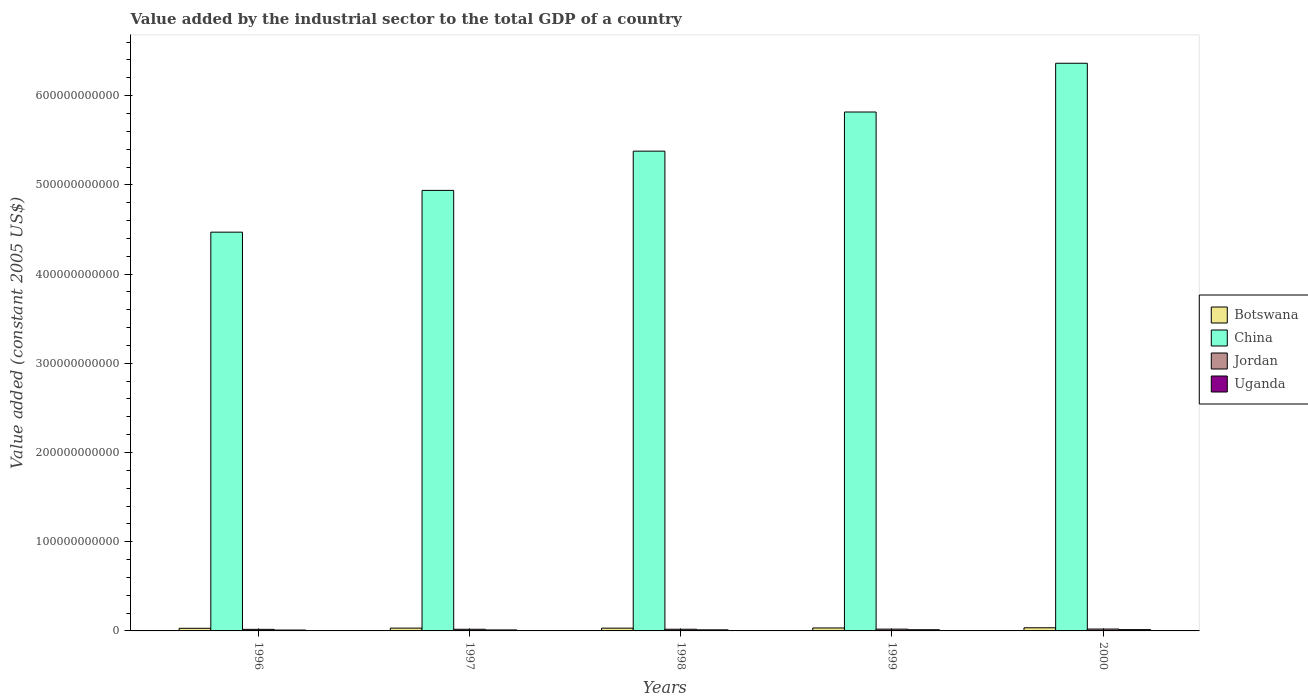Are the number of bars per tick equal to the number of legend labels?
Give a very brief answer. Yes. Are the number of bars on each tick of the X-axis equal?
Keep it short and to the point. Yes. How many bars are there on the 2nd tick from the left?
Make the answer very short. 4. What is the value added by the industrial sector in Uganda in 1997?
Offer a terse response. 1.10e+09. Across all years, what is the maximum value added by the industrial sector in Uganda?
Provide a succinct answer. 1.45e+09. Across all years, what is the minimum value added by the industrial sector in Uganda?
Give a very brief answer. 9.84e+08. In which year was the value added by the industrial sector in China maximum?
Your answer should be compact. 2000. In which year was the value added by the industrial sector in Jordan minimum?
Your answer should be compact. 1996. What is the total value added by the industrial sector in Jordan in the graph?
Keep it short and to the point. 9.58e+09. What is the difference between the value added by the industrial sector in Botswana in 1998 and that in 1999?
Provide a succinct answer. -2.07e+08. What is the difference between the value added by the industrial sector in Botswana in 1998 and the value added by the industrial sector in China in 1999?
Offer a very short reply. -5.79e+11. What is the average value added by the industrial sector in Uganda per year?
Offer a terse response. 1.21e+09. In the year 1999, what is the difference between the value added by the industrial sector in Botswana and value added by the industrial sector in Jordan?
Provide a succinct answer. 1.30e+09. What is the ratio of the value added by the industrial sector in China in 1997 to that in 1999?
Give a very brief answer. 0.85. Is the difference between the value added by the industrial sector in Botswana in 1998 and 2000 greater than the difference between the value added by the industrial sector in Jordan in 1998 and 2000?
Keep it short and to the point. No. What is the difference between the highest and the second highest value added by the industrial sector in Botswana?
Keep it short and to the point. 2.25e+08. What is the difference between the highest and the lowest value added by the industrial sector in Botswana?
Provide a succinct answer. 5.79e+08. Is it the case that in every year, the sum of the value added by the industrial sector in China and value added by the industrial sector in Botswana is greater than the sum of value added by the industrial sector in Jordan and value added by the industrial sector in Uganda?
Make the answer very short. Yes. What does the 1st bar from the left in 1996 represents?
Keep it short and to the point. Botswana. What does the 2nd bar from the right in 1996 represents?
Your response must be concise. Jordan. Is it the case that in every year, the sum of the value added by the industrial sector in Botswana and value added by the industrial sector in Jordan is greater than the value added by the industrial sector in China?
Provide a succinct answer. No. Are all the bars in the graph horizontal?
Ensure brevity in your answer.  No. What is the difference between two consecutive major ticks on the Y-axis?
Provide a short and direct response. 1.00e+11. Are the values on the major ticks of Y-axis written in scientific E-notation?
Provide a succinct answer. No. Does the graph contain any zero values?
Keep it short and to the point. No. Where does the legend appear in the graph?
Provide a succinct answer. Center right. How many legend labels are there?
Provide a succinct answer. 4. How are the legend labels stacked?
Provide a succinct answer. Vertical. What is the title of the graph?
Offer a very short reply. Value added by the industrial sector to the total GDP of a country. Does "Macedonia" appear as one of the legend labels in the graph?
Offer a terse response. No. What is the label or title of the Y-axis?
Give a very brief answer. Value added (constant 2005 US$). What is the Value added (constant 2005 US$) in Botswana in 1996?
Make the answer very short. 2.96e+09. What is the Value added (constant 2005 US$) of China in 1996?
Your answer should be compact. 4.47e+11. What is the Value added (constant 2005 US$) of Jordan in 1996?
Provide a short and direct response. 1.76e+09. What is the Value added (constant 2005 US$) in Uganda in 1996?
Provide a short and direct response. 9.84e+08. What is the Value added (constant 2005 US$) of Botswana in 1997?
Make the answer very short. 3.15e+09. What is the Value added (constant 2005 US$) in China in 1997?
Provide a succinct answer. 4.94e+11. What is the Value added (constant 2005 US$) in Jordan in 1997?
Give a very brief answer. 1.85e+09. What is the Value added (constant 2005 US$) of Uganda in 1997?
Keep it short and to the point. 1.10e+09. What is the Value added (constant 2005 US$) in Botswana in 1998?
Keep it short and to the point. 3.10e+09. What is the Value added (constant 2005 US$) in China in 1998?
Your response must be concise. 5.38e+11. What is the Value added (constant 2005 US$) in Jordan in 1998?
Your answer should be compact. 1.88e+09. What is the Value added (constant 2005 US$) in Uganda in 1998?
Keep it short and to the point. 1.19e+09. What is the Value added (constant 2005 US$) in Botswana in 1999?
Offer a very short reply. 3.31e+09. What is the Value added (constant 2005 US$) in China in 1999?
Your answer should be very brief. 5.82e+11. What is the Value added (constant 2005 US$) of Jordan in 1999?
Make the answer very short. 2.01e+09. What is the Value added (constant 2005 US$) in Uganda in 1999?
Give a very brief answer. 1.31e+09. What is the Value added (constant 2005 US$) in Botswana in 2000?
Provide a succinct answer. 3.54e+09. What is the Value added (constant 2005 US$) of China in 2000?
Your answer should be compact. 6.36e+11. What is the Value added (constant 2005 US$) in Jordan in 2000?
Provide a succinct answer. 2.09e+09. What is the Value added (constant 2005 US$) in Uganda in 2000?
Give a very brief answer. 1.45e+09. Across all years, what is the maximum Value added (constant 2005 US$) of Botswana?
Keep it short and to the point. 3.54e+09. Across all years, what is the maximum Value added (constant 2005 US$) of China?
Ensure brevity in your answer.  6.36e+11. Across all years, what is the maximum Value added (constant 2005 US$) of Jordan?
Your answer should be compact. 2.09e+09. Across all years, what is the maximum Value added (constant 2005 US$) of Uganda?
Offer a very short reply. 1.45e+09. Across all years, what is the minimum Value added (constant 2005 US$) of Botswana?
Your response must be concise. 2.96e+09. Across all years, what is the minimum Value added (constant 2005 US$) in China?
Your answer should be very brief. 4.47e+11. Across all years, what is the minimum Value added (constant 2005 US$) in Jordan?
Keep it short and to the point. 1.76e+09. Across all years, what is the minimum Value added (constant 2005 US$) in Uganda?
Give a very brief answer. 9.84e+08. What is the total Value added (constant 2005 US$) of Botswana in the graph?
Your answer should be compact. 1.61e+1. What is the total Value added (constant 2005 US$) in China in the graph?
Your answer should be very brief. 2.70e+12. What is the total Value added (constant 2005 US$) in Jordan in the graph?
Provide a short and direct response. 9.58e+09. What is the total Value added (constant 2005 US$) in Uganda in the graph?
Your answer should be very brief. 6.03e+09. What is the difference between the Value added (constant 2005 US$) of Botswana in 1996 and that in 1997?
Provide a short and direct response. -1.94e+08. What is the difference between the Value added (constant 2005 US$) in China in 1996 and that in 1997?
Your answer should be compact. -4.68e+1. What is the difference between the Value added (constant 2005 US$) in Jordan in 1996 and that in 1997?
Offer a very short reply. -9.61e+07. What is the difference between the Value added (constant 2005 US$) in Uganda in 1996 and that in 1997?
Offer a terse response. -1.12e+08. What is the difference between the Value added (constant 2005 US$) of Botswana in 1996 and that in 1998?
Make the answer very short. -1.46e+08. What is the difference between the Value added (constant 2005 US$) in China in 1996 and that in 1998?
Your answer should be very brief. -9.08e+1. What is the difference between the Value added (constant 2005 US$) in Jordan in 1996 and that in 1998?
Keep it short and to the point. -1.24e+08. What is the difference between the Value added (constant 2005 US$) of Uganda in 1996 and that in 1998?
Provide a short and direct response. -2.07e+08. What is the difference between the Value added (constant 2005 US$) of Botswana in 1996 and that in 1999?
Your answer should be compact. -3.53e+08. What is the difference between the Value added (constant 2005 US$) of China in 1996 and that in 1999?
Provide a succinct answer. -1.35e+11. What is the difference between the Value added (constant 2005 US$) in Jordan in 1996 and that in 1999?
Offer a terse response. -2.50e+08. What is the difference between the Value added (constant 2005 US$) of Uganda in 1996 and that in 1999?
Keep it short and to the point. -3.31e+08. What is the difference between the Value added (constant 2005 US$) in Botswana in 1996 and that in 2000?
Offer a terse response. -5.79e+08. What is the difference between the Value added (constant 2005 US$) in China in 1996 and that in 2000?
Provide a short and direct response. -1.89e+11. What is the difference between the Value added (constant 2005 US$) in Jordan in 1996 and that in 2000?
Make the answer very short. -3.32e+08. What is the difference between the Value added (constant 2005 US$) of Uganda in 1996 and that in 2000?
Your answer should be very brief. -4.65e+08. What is the difference between the Value added (constant 2005 US$) of Botswana in 1997 and that in 1998?
Your answer should be very brief. 4.81e+07. What is the difference between the Value added (constant 2005 US$) of China in 1997 and that in 1998?
Ensure brevity in your answer.  -4.40e+1. What is the difference between the Value added (constant 2005 US$) of Jordan in 1997 and that in 1998?
Offer a terse response. -2.83e+07. What is the difference between the Value added (constant 2005 US$) of Uganda in 1997 and that in 1998?
Offer a terse response. -9.55e+07. What is the difference between the Value added (constant 2005 US$) of Botswana in 1997 and that in 1999?
Your answer should be very brief. -1.59e+08. What is the difference between the Value added (constant 2005 US$) in China in 1997 and that in 1999?
Your answer should be compact. -8.79e+1. What is the difference between the Value added (constant 2005 US$) in Jordan in 1997 and that in 1999?
Offer a very short reply. -1.54e+08. What is the difference between the Value added (constant 2005 US$) in Uganda in 1997 and that in 1999?
Your answer should be very brief. -2.19e+08. What is the difference between the Value added (constant 2005 US$) in Botswana in 1997 and that in 2000?
Provide a short and direct response. -3.84e+08. What is the difference between the Value added (constant 2005 US$) in China in 1997 and that in 2000?
Provide a short and direct response. -1.43e+11. What is the difference between the Value added (constant 2005 US$) of Jordan in 1997 and that in 2000?
Keep it short and to the point. -2.36e+08. What is the difference between the Value added (constant 2005 US$) of Uganda in 1997 and that in 2000?
Offer a terse response. -3.53e+08. What is the difference between the Value added (constant 2005 US$) of Botswana in 1998 and that in 1999?
Provide a short and direct response. -2.07e+08. What is the difference between the Value added (constant 2005 US$) of China in 1998 and that in 1999?
Offer a terse response. -4.39e+1. What is the difference between the Value added (constant 2005 US$) of Jordan in 1998 and that in 1999?
Provide a short and direct response. -1.25e+08. What is the difference between the Value added (constant 2005 US$) of Uganda in 1998 and that in 1999?
Ensure brevity in your answer.  -1.24e+08. What is the difference between the Value added (constant 2005 US$) of Botswana in 1998 and that in 2000?
Offer a very short reply. -4.32e+08. What is the difference between the Value added (constant 2005 US$) of China in 1998 and that in 2000?
Provide a succinct answer. -9.85e+1. What is the difference between the Value added (constant 2005 US$) in Jordan in 1998 and that in 2000?
Make the answer very short. -2.08e+08. What is the difference between the Value added (constant 2005 US$) of Uganda in 1998 and that in 2000?
Offer a very short reply. -2.57e+08. What is the difference between the Value added (constant 2005 US$) of Botswana in 1999 and that in 2000?
Keep it short and to the point. -2.25e+08. What is the difference between the Value added (constant 2005 US$) of China in 1999 and that in 2000?
Your answer should be compact. -5.47e+1. What is the difference between the Value added (constant 2005 US$) in Jordan in 1999 and that in 2000?
Ensure brevity in your answer.  -8.23e+07. What is the difference between the Value added (constant 2005 US$) of Uganda in 1999 and that in 2000?
Your response must be concise. -1.34e+08. What is the difference between the Value added (constant 2005 US$) in Botswana in 1996 and the Value added (constant 2005 US$) in China in 1997?
Provide a short and direct response. -4.91e+11. What is the difference between the Value added (constant 2005 US$) in Botswana in 1996 and the Value added (constant 2005 US$) in Jordan in 1997?
Offer a very short reply. 1.10e+09. What is the difference between the Value added (constant 2005 US$) in Botswana in 1996 and the Value added (constant 2005 US$) in Uganda in 1997?
Your answer should be compact. 1.86e+09. What is the difference between the Value added (constant 2005 US$) in China in 1996 and the Value added (constant 2005 US$) in Jordan in 1997?
Keep it short and to the point. 4.45e+11. What is the difference between the Value added (constant 2005 US$) of China in 1996 and the Value added (constant 2005 US$) of Uganda in 1997?
Your answer should be very brief. 4.46e+11. What is the difference between the Value added (constant 2005 US$) in Jordan in 1996 and the Value added (constant 2005 US$) in Uganda in 1997?
Give a very brief answer. 6.60e+08. What is the difference between the Value added (constant 2005 US$) in Botswana in 1996 and the Value added (constant 2005 US$) in China in 1998?
Provide a succinct answer. -5.35e+11. What is the difference between the Value added (constant 2005 US$) in Botswana in 1996 and the Value added (constant 2005 US$) in Jordan in 1998?
Give a very brief answer. 1.08e+09. What is the difference between the Value added (constant 2005 US$) of Botswana in 1996 and the Value added (constant 2005 US$) of Uganda in 1998?
Your answer should be very brief. 1.77e+09. What is the difference between the Value added (constant 2005 US$) of China in 1996 and the Value added (constant 2005 US$) of Jordan in 1998?
Make the answer very short. 4.45e+11. What is the difference between the Value added (constant 2005 US$) of China in 1996 and the Value added (constant 2005 US$) of Uganda in 1998?
Your answer should be compact. 4.46e+11. What is the difference between the Value added (constant 2005 US$) of Jordan in 1996 and the Value added (constant 2005 US$) of Uganda in 1998?
Ensure brevity in your answer.  5.65e+08. What is the difference between the Value added (constant 2005 US$) in Botswana in 1996 and the Value added (constant 2005 US$) in China in 1999?
Offer a terse response. -5.79e+11. What is the difference between the Value added (constant 2005 US$) of Botswana in 1996 and the Value added (constant 2005 US$) of Jordan in 1999?
Ensure brevity in your answer.  9.51e+08. What is the difference between the Value added (constant 2005 US$) of Botswana in 1996 and the Value added (constant 2005 US$) of Uganda in 1999?
Provide a succinct answer. 1.64e+09. What is the difference between the Value added (constant 2005 US$) of China in 1996 and the Value added (constant 2005 US$) of Jordan in 1999?
Your answer should be compact. 4.45e+11. What is the difference between the Value added (constant 2005 US$) in China in 1996 and the Value added (constant 2005 US$) in Uganda in 1999?
Give a very brief answer. 4.46e+11. What is the difference between the Value added (constant 2005 US$) in Jordan in 1996 and the Value added (constant 2005 US$) in Uganda in 1999?
Provide a short and direct response. 4.41e+08. What is the difference between the Value added (constant 2005 US$) of Botswana in 1996 and the Value added (constant 2005 US$) of China in 2000?
Make the answer very short. -6.33e+11. What is the difference between the Value added (constant 2005 US$) of Botswana in 1996 and the Value added (constant 2005 US$) of Jordan in 2000?
Ensure brevity in your answer.  8.69e+08. What is the difference between the Value added (constant 2005 US$) in Botswana in 1996 and the Value added (constant 2005 US$) in Uganda in 2000?
Offer a terse response. 1.51e+09. What is the difference between the Value added (constant 2005 US$) in China in 1996 and the Value added (constant 2005 US$) in Jordan in 2000?
Your answer should be very brief. 4.45e+11. What is the difference between the Value added (constant 2005 US$) in China in 1996 and the Value added (constant 2005 US$) in Uganda in 2000?
Offer a very short reply. 4.46e+11. What is the difference between the Value added (constant 2005 US$) of Jordan in 1996 and the Value added (constant 2005 US$) of Uganda in 2000?
Provide a short and direct response. 3.07e+08. What is the difference between the Value added (constant 2005 US$) of Botswana in 1997 and the Value added (constant 2005 US$) of China in 1998?
Your answer should be compact. -5.35e+11. What is the difference between the Value added (constant 2005 US$) in Botswana in 1997 and the Value added (constant 2005 US$) in Jordan in 1998?
Your answer should be very brief. 1.27e+09. What is the difference between the Value added (constant 2005 US$) in Botswana in 1997 and the Value added (constant 2005 US$) in Uganda in 1998?
Provide a succinct answer. 1.96e+09. What is the difference between the Value added (constant 2005 US$) in China in 1997 and the Value added (constant 2005 US$) in Jordan in 1998?
Your response must be concise. 4.92e+11. What is the difference between the Value added (constant 2005 US$) in China in 1997 and the Value added (constant 2005 US$) in Uganda in 1998?
Provide a short and direct response. 4.93e+11. What is the difference between the Value added (constant 2005 US$) of Jordan in 1997 and the Value added (constant 2005 US$) of Uganda in 1998?
Your answer should be compact. 6.61e+08. What is the difference between the Value added (constant 2005 US$) in Botswana in 1997 and the Value added (constant 2005 US$) in China in 1999?
Ensure brevity in your answer.  -5.79e+11. What is the difference between the Value added (constant 2005 US$) in Botswana in 1997 and the Value added (constant 2005 US$) in Jordan in 1999?
Give a very brief answer. 1.15e+09. What is the difference between the Value added (constant 2005 US$) of Botswana in 1997 and the Value added (constant 2005 US$) of Uganda in 1999?
Make the answer very short. 1.84e+09. What is the difference between the Value added (constant 2005 US$) of China in 1997 and the Value added (constant 2005 US$) of Jordan in 1999?
Your answer should be very brief. 4.92e+11. What is the difference between the Value added (constant 2005 US$) in China in 1997 and the Value added (constant 2005 US$) in Uganda in 1999?
Make the answer very short. 4.93e+11. What is the difference between the Value added (constant 2005 US$) of Jordan in 1997 and the Value added (constant 2005 US$) of Uganda in 1999?
Your response must be concise. 5.37e+08. What is the difference between the Value added (constant 2005 US$) of Botswana in 1997 and the Value added (constant 2005 US$) of China in 2000?
Keep it short and to the point. -6.33e+11. What is the difference between the Value added (constant 2005 US$) of Botswana in 1997 and the Value added (constant 2005 US$) of Jordan in 2000?
Offer a terse response. 1.06e+09. What is the difference between the Value added (constant 2005 US$) in Botswana in 1997 and the Value added (constant 2005 US$) in Uganda in 2000?
Give a very brief answer. 1.70e+09. What is the difference between the Value added (constant 2005 US$) of China in 1997 and the Value added (constant 2005 US$) of Jordan in 2000?
Give a very brief answer. 4.92e+11. What is the difference between the Value added (constant 2005 US$) in China in 1997 and the Value added (constant 2005 US$) in Uganda in 2000?
Your response must be concise. 4.92e+11. What is the difference between the Value added (constant 2005 US$) of Jordan in 1997 and the Value added (constant 2005 US$) of Uganda in 2000?
Provide a short and direct response. 4.03e+08. What is the difference between the Value added (constant 2005 US$) in Botswana in 1998 and the Value added (constant 2005 US$) in China in 1999?
Offer a terse response. -5.79e+11. What is the difference between the Value added (constant 2005 US$) of Botswana in 1998 and the Value added (constant 2005 US$) of Jordan in 1999?
Offer a terse response. 1.10e+09. What is the difference between the Value added (constant 2005 US$) of Botswana in 1998 and the Value added (constant 2005 US$) of Uganda in 1999?
Ensure brevity in your answer.  1.79e+09. What is the difference between the Value added (constant 2005 US$) of China in 1998 and the Value added (constant 2005 US$) of Jordan in 1999?
Your answer should be very brief. 5.36e+11. What is the difference between the Value added (constant 2005 US$) of China in 1998 and the Value added (constant 2005 US$) of Uganda in 1999?
Offer a terse response. 5.37e+11. What is the difference between the Value added (constant 2005 US$) in Jordan in 1998 and the Value added (constant 2005 US$) in Uganda in 1999?
Make the answer very short. 5.65e+08. What is the difference between the Value added (constant 2005 US$) in Botswana in 1998 and the Value added (constant 2005 US$) in China in 2000?
Provide a short and direct response. -6.33e+11. What is the difference between the Value added (constant 2005 US$) of Botswana in 1998 and the Value added (constant 2005 US$) of Jordan in 2000?
Offer a terse response. 1.02e+09. What is the difference between the Value added (constant 2005 US$) in Botswana in 1998 and the Value added (constant 2005 US$) in Uganda in 2000?
Give a very brief answer. 1.65e+09. What is the difference between the Value added (constant 2005 US$) of China in 1998 and the Value added (constant 2005 US$) of Jordan in 2000?
Make the answer very short. 5.36e+11. What is the difference between the Value added (constant 2005 US$) in China in 1998 and the Value added (constant 2005 US$) in Uganda in 2000?
Provide a succinct answer. 5.36e+11. What is the difference between the Value added (constant 2005 US$) in Jordan in 1998 and the Value added (constant 2005 US$) in Uganda in 2000?
Keep it short and to the point. 4.32e+08. What is the difference between the Value added (constant 2005 US$) in Botswana in 1999 and the Value added (constant 2005 US$) in China in 2000?
Give a very brief answer. -6.33e+11. What is the difference between the Value added (constant 2005 US$) in Botswana in 1999 and the Value added (constant 2005 US$) in Jordan in 2000?
Offer a very short reply. 1.22e+09. What is the difference between the Value added (constant 2005 US$) in Botswana in 1999 and the Value added (constant 2005 US$) in Uganda in 2000?
Offer a very short reply. 1.86e+09. What is the difference between the Value added (constant 2005 US$) in China in 1999 and the Value added (constant 2005 US$) in Jordan in 2000?
Offer a terse response. 5.80e+11. What is the difference between the Value added (constant 2005 US$) of China in 1999 and the Value added (constant 2005 US$) of Uganda in 2000?
Offer a terse response. 5.80e+11. What is the difference between the Value added (constant 2005 US$) in Jordan in 1999 and the Value added (constant 2005 US$) in Uganda in 2000?
Make the answer very short. 5.57e+08. What is the average Value added (constant 2005 US$) of Botswana per year?
Your response must be concise. 3.21e+09. What is the average Value added (constant 2005 US$) in China per year?
Your answer should be compact. 5.39e+11. What is the average Value added (constant 2005 US$) in Jordan per year?
Keep it short and to the point. 1.92e+09. What is the average Value added (constant 2005 US$) of Uganda per year?
Offer a very short reply. 1.21e+09. In the year 1996, what is the difference between the Value added (constant 2005 US$) in Botswana and Value added (constant 2005 US$) in China?
Provide a short and direct response. -4.44e+11. In the year 1996, what is the difference between the Value added (constant 2005 US$) of Botswana and Value added (constant 2005 US$) of Jordan?
Your response must be concise. 1.20e+09. In the year 1996, what is the difference between the Value added (constant 2005 US$) in Botswana and Value added (constant 2005 US$) in Uganda?
Make the answer very short. 1.97e+09. In the year 1996, what is the difference between the Value added (constant 2005 US$) in China and Value added (constant 2005 US$) in Jordan?
Your response must be concise. 4.45e+11. In the year 1996, what is the difference between the Value added (constant 2005 US$) in China and Value added (constant 2005 US$) in Uganda?
Provide a short and direct response. 4.46e+11. In the year 1996, what is the difference between the Value added (constant 2005 US$) in Jordan and Value added (constant 2005 US$) in Uganda?
Make the answer very short. 7.72e+08. In the year 1997, what is the difference between the Value added (constant 2005 US$) in Botswana and Value added (constant 2005 US$) in China?
Your answer should be very brief. -4.91e+11. In the year 1997, what is the difference between the Value added (constant 2005 US$) of Botswana and Value added (constant 2005 US$) of Jordan?
Your answer should be very brief. 1.30e+09. In the year 1997, what is the difference between the Value added (constant 2005 US$) in Botswana and Value added (constant 2005 US$) in Uganda?
Offer a terse response. 2.06e+09. In the year 1997, what is the difference between the Value added (constant 2005 US$) of China and Value added (constant 2005 US$) of Jordan?
Ensure brevity in your answer.  4.92e+11. In the year 1997, what is the difference between the Value added (constant 2005 US$) in China and Value added (constant 2005 US$) in Uganda?
Your answer should be very brief. 4.93e+11. In the year 1997, what is the difference between the Value added (constant 2005 US$) of Jordan and Value added (constant 2005 US$) of Uganda?
Keep it short and to the point. 7.56e+08. In the year 1998, what is the difference between the Value added (constant 2005 US$) in Botswana and Value added (constant 2005 US$) in China?
Your answer should be very brief. -5.35e+11. In the year 1998, what is the difference between the Value added (constant 2005 US$) of Botswana and Value added (constant 2005 US$) of Jordan?
Your answer should be very brief. 1.22e+09. In the year 1998, what is the difference between the Value added (constant 2005 US$) of Botswana and Value added (constant 2005 US$) of Uganda?
Keep it short and to the point. 1.91e+09. In the year 1998, what is the difference between the Value added (constant 2005 US$) in China and Value added (constant 2005 US$) in Jordan?
Offer a terse response. 5.36e+11. In the year 1998, what is the difference between the Value added (constant 2005 US$) of China and Value added (constant 2005 US$) of Uganda?
Make the answer very short. 5.37e+11. In the year 1998, what is the difference between the Value added (constant 2005 US$) of Jordan and Value added (constant 2005 US$) of Uganda?
Offer a very short reply. 6.89e+08. In the year 1999, what is the difference between the Value added (constant 2005 US$) of Botswana and Value added (constant 2005 US$) of China?
Provide a short and direct response. -5.78e+11. In the year 1999, what is the difference between the Value added (constant 2005 US$) in Botswana and Value added (constant 2005 US$) in Jordan?
Provide a short and direct response. 1.30e+09. In the year 1999, what is the difference between the Value added (constant 2005 US$) in Botswana and Value added (constant 2005 US$) in Uganda?
Ensure brevity in your answer.  2.00e+09. In the year 1999, what is the difference between the Value added (constant 2005 US$) of China and Value added (constant 2005 US$) of Jordan?
Offer a very short reply. 5.80e+11. In the year 1999, what is the difference between the Value added (constant 2005 US$) of China and Value added (constant 2005 US$) of Uganda?
Provide a succinct answer. 5.80e+11. In the year 1999, what is the difference between the Value added (constant 2005 US$) in Jordan and Value added (constant 2005 US$) in Uganda?
Offer a terse response. 6.91e+08. In the year 2000, what is the difference between the Value added (constant 2005 US$) of Botswana and Value added (constant 2005 US$) of China?
Make the answer very short. -6.33e+11. In the year 2000, what is the difference between the Value added (constant 2005 US$) in Botswana and Value added (constant 2005 US$) in Jordan?
Offer a terse response. 1.45e+09. In the year 2000, what is the difference between the Value added (constant 2005 US$) in Botswana and Value added (constant 2005 US$) in Uganda?
Keep it short and to the point. 2.09e+09. In the year 2000, what is the difference between the Value added (constant 2005 US$) of China and Value added (constant 2005 US$) of Jordan?
Ensure brevity in your answer.  6.34e+11. In the year 2000, what is the difference between the Value added (constant 2005 US$) in China and Value added (constant 2005 US$) in Uganda?
Provide a short and direct response. 6.35e+11. In the year 2000, what is the difference between the Value added (constant 2005 US$) of Jordan and Value added (constant 2005 US$) of Uganda?
Ensure brevity in your answer.  6.39e+08. What is the ratio of the Value added (constant 2005 US$) in Botswana in 1996 to that in 1997?
Your response must be concise. 0.94. What is the ratio of the Value added (constant 2005 US$) in China in 1996 to that in 1997?
Provide a short and direct response. 0.91. What is the ratio of the Value added (constant 2005 US$) in Jordan in 1996 to that in 1997?
Make the answer very short. 0.95. What is the ratio of the Value added (constant 2005 US$) of Uganda in 1996 to that in 1997?
Your answer should be very brief. 0.9. What is the ratio of the Value added (constant 2005 US$) of Botswana in 1996 to that in 1998?
Keep it short and to the point. 0.95. What is the ratio of the Value added (constant 2005 US$) in China in 1996 to that in 1998?
Offer a very short reply. 0.83. What is the ratio of the Value added (constant 2005 US$) of Jordan in 1996 to that in 1998?
Ensure brevity in your answer.  0.93. What is the ratio of the Value added (constant 2005 US$) in Uganda in 1996 to that in 1998?
Your answer should be very brief. 0.83. What is the ratio of the Value added (constant 2005 US$) in Botswana in 1996 to that in 1999?
Keep it short and to the point. 0.89. What is the ratio of the Value added (constant 2005 US$) in China in 1996 to that in 1999?
Give a very brief answer. 0.77. What is the ratio of the Value added (constant 2005 US$) in Jordan in 1996 to that in 1999?
Your response must be concise. 0.88. What is the ratio of the Value added (constant 2005 US$) of Uganda in 1996 to that in 1999?
Provide a short and direct response. 0.75. What is the ratio of the Value added (constant 2005 US$) of Botswana in 1996 to that in 2000?
Make the answer very short. 0.84. What is the ratio of the Value added (constant 2005 US$) in China in 1996 to that in 2000?
Ensure brevity in your answer.  0.7. What is the ratio of the Value added (constant 2005 US$) in Jordan in 1996 to that in 2000?
Offer a very short reply. 0.84. What is the ratio of the Value added (constant 2005 US$) in Uganda in 1996 to that in 2000?
Ensure brevity in your answer.  0.68. What is the ratio of the Value added (constant 2005 US$) of Botswana in 1997 to that in 1998?
Your response must be concise. 1.02. What is the ratio of the Value added (constant 2005 US$) in China in 1997 to that in 1998?
Offer a terse response. 0.92. What is the ratio of the Value added (constant 2005 US$) of Jordan in 1997 to that in 1998?
Your answer should be very brief. 0.98. What is the ratio of the Value added (constant 2005 US$) of Uganda in 1997 to that in 1998?
Your answer should be compact. 0.92. What is the ratio of the Value added (constant 2005 US$) in Botswana in 1997 to that in 1999?
Keep it short and to the point. 0.95. What is the ratio of the Value added (constant 2005 US$) in China in 1997 to that in 1999?
Make the answer very short. 0.85. What is the ratio of the Value added (constant 2005 US$) of Jordan in 1997 to that in 1999?
Your response must be concise. 0.92. What is the ratio of the Value added (constant 2005 US$) of Botswana in 1997 to that in 2000?
Your answer should be compact. 0.89. What is the ratio of the Value added (constant 2005 US$) of China in 1997 to that in 2000?
Your response must be concise. 0.78. What is the ratio of the Value added (constant 2005 US$) in Jordan in 1997 to that in 2000?
Your answer should be very brief. 0.89. What is the ratio of the Value added (constant 2005 US$) of Uganda in 1997 to that in 2000?
Offer a very short reply. 0.76. What is the ratio of the Value added (constant 2005 US$) of Botswana in 1998 to that in 1999?
Make the answer very short. 0.94. What is the ratio of the Value added (constant 2005 US$) of China in 1998 to that in 1999?
Offer a terse response. 0.92. What is the ratio of the Value added (constant 2005 US$) of Uganda in 1998 to that in 1999?
Offer a very short reply. 0.91. What is the ratio of the Value added (constant 2005 US$) in Botswana in 1998 to that in 2000?
Your response must be concise. 0.88. What is the ratio of the Value added (constant 2005 US$) in China in 1998 to that in 2000?
Offer a terse response. 0.85. What is the ratio of the Value added (constant 2005 US$) in Jordan in 1998 to that in 2000?
Provide a short and direct response. 0.9. What is the ratio of the Value added (constant 2005 US$) in Uganda in 1998 to that in 2000?
Offer a terse response. 0.82. What is the ratio of the Value added (constant 2005 US$) in Botswana in 1999 to that in 2000?
Your response must be concise. 0.94. What is the ratio of the Value added (constant 2005 US$) of China in 1999 to that in 2000?
Provide a succinct answer. 0.91. What is the ratio of the Value added (constant 2005 US$) of Jordan in 1999 to that in 2000?
Offer a terse response. 0.96. What is the ratio of the Value added (constant 2005 US$) in Uganda in 1999 to that in 2000?
Your response must be concise. 0.91. What is the difference between the highest and the second highest Value added (constant 2005 US$) in Botswana?
Ensure brevity in your answer.  2.25e+08. What is the difference between the highest and the second highest Value added (constant 2005 US$) of China?
Offer a terse response. 5.47e+1. What is the difference between the highest and the second highest Value added (constant 2005 US$) in Jordan?
Your answer should be very brief. 8.23e+07. What is the difference between the highest and the second highest Value added (constant 2005 US$) in Uganda?
Make the answer very short. 1.34e+08. What is the difference between the highest and the lowest Value added (constant 2005 US$) of Botswana?
Your answer should be very brief. 5.79e+08. What is the difference between the highest and the lowest Value added (constant 2005 US$) in China?
Ensure brevity in your answer.  1.89e+11. What is the difference between the highest and the lowest Value added (constant 2005 US$) of Jordan?
Give a very brief answer. 3.32e+08. What is the difference between the highest and the lowest Value added (constant 2005 US$) of Uganda?
Make the answer very short. 4.65e+08. 